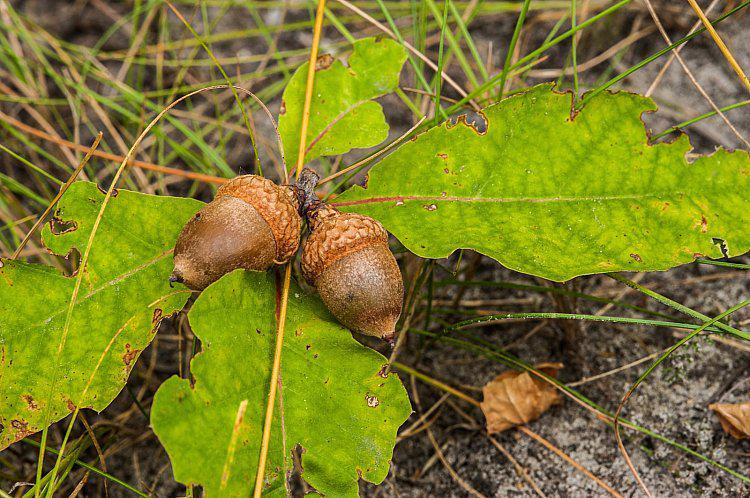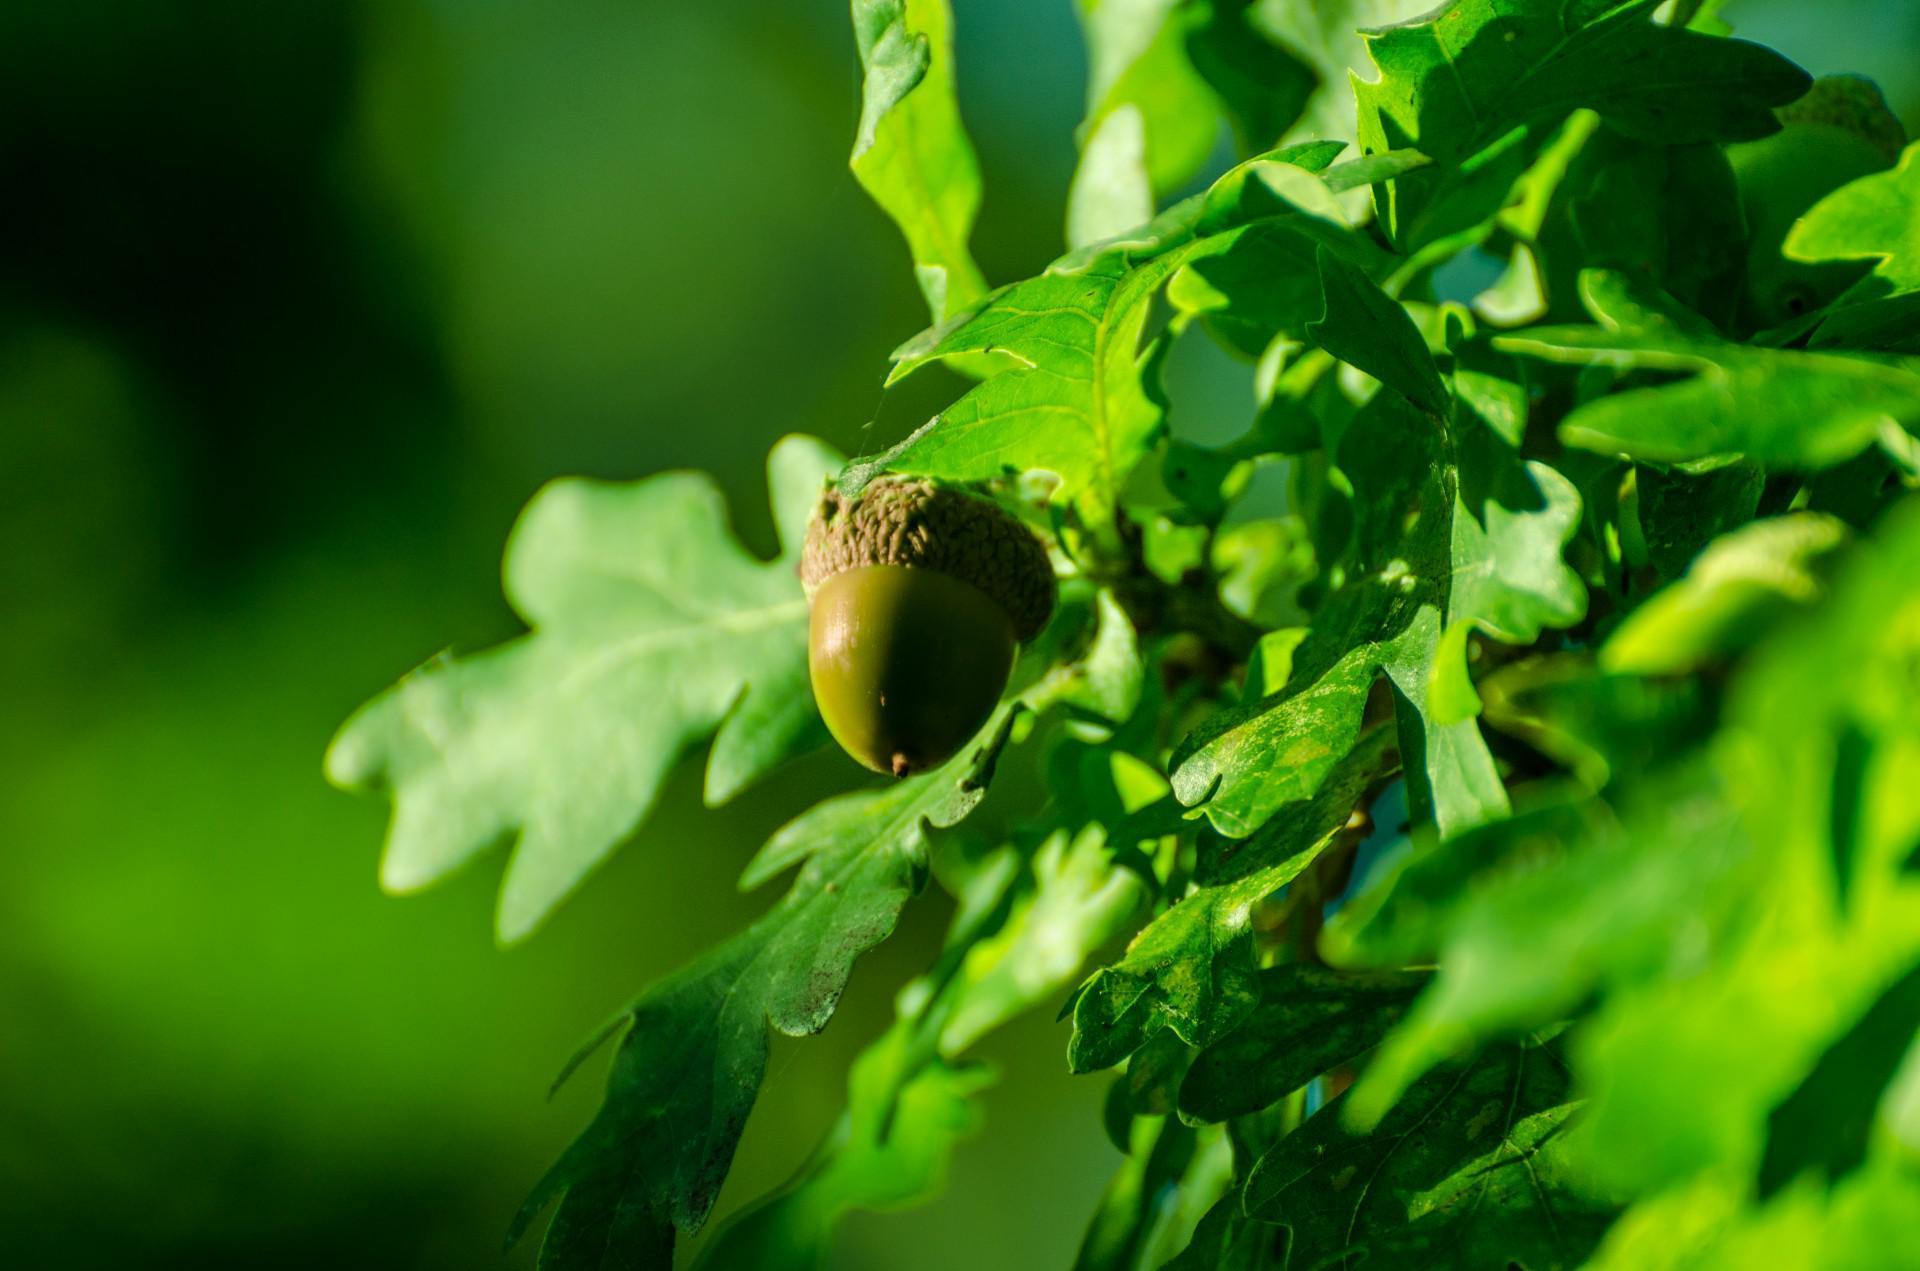The first image is the image on the left, the second image is the image on the right. Given the left and right images, does the statement "One image shows exactly two brown acorns in back-to-back caps on green foliage." hold true? Answer yes or no. Yes. The first image is the image on the left, the second image is the image on the right. Considering the images on both sides, is "in at least one image there are two of acorns attached together." valid? Answer yes or no. Yes. 